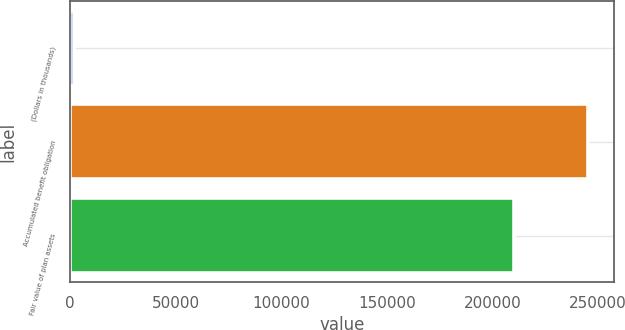Convert chart to OTSL. <chart><loc_0><loc_0><loc_500><loc_500><bar_chart><fcel>(Dollars in thousands)<fcel>Accumulated benefit obligation<fcel>Fair value of plan assets<nl><fcel>2017<fcel>245430<fcel>210267<nl></chart> 